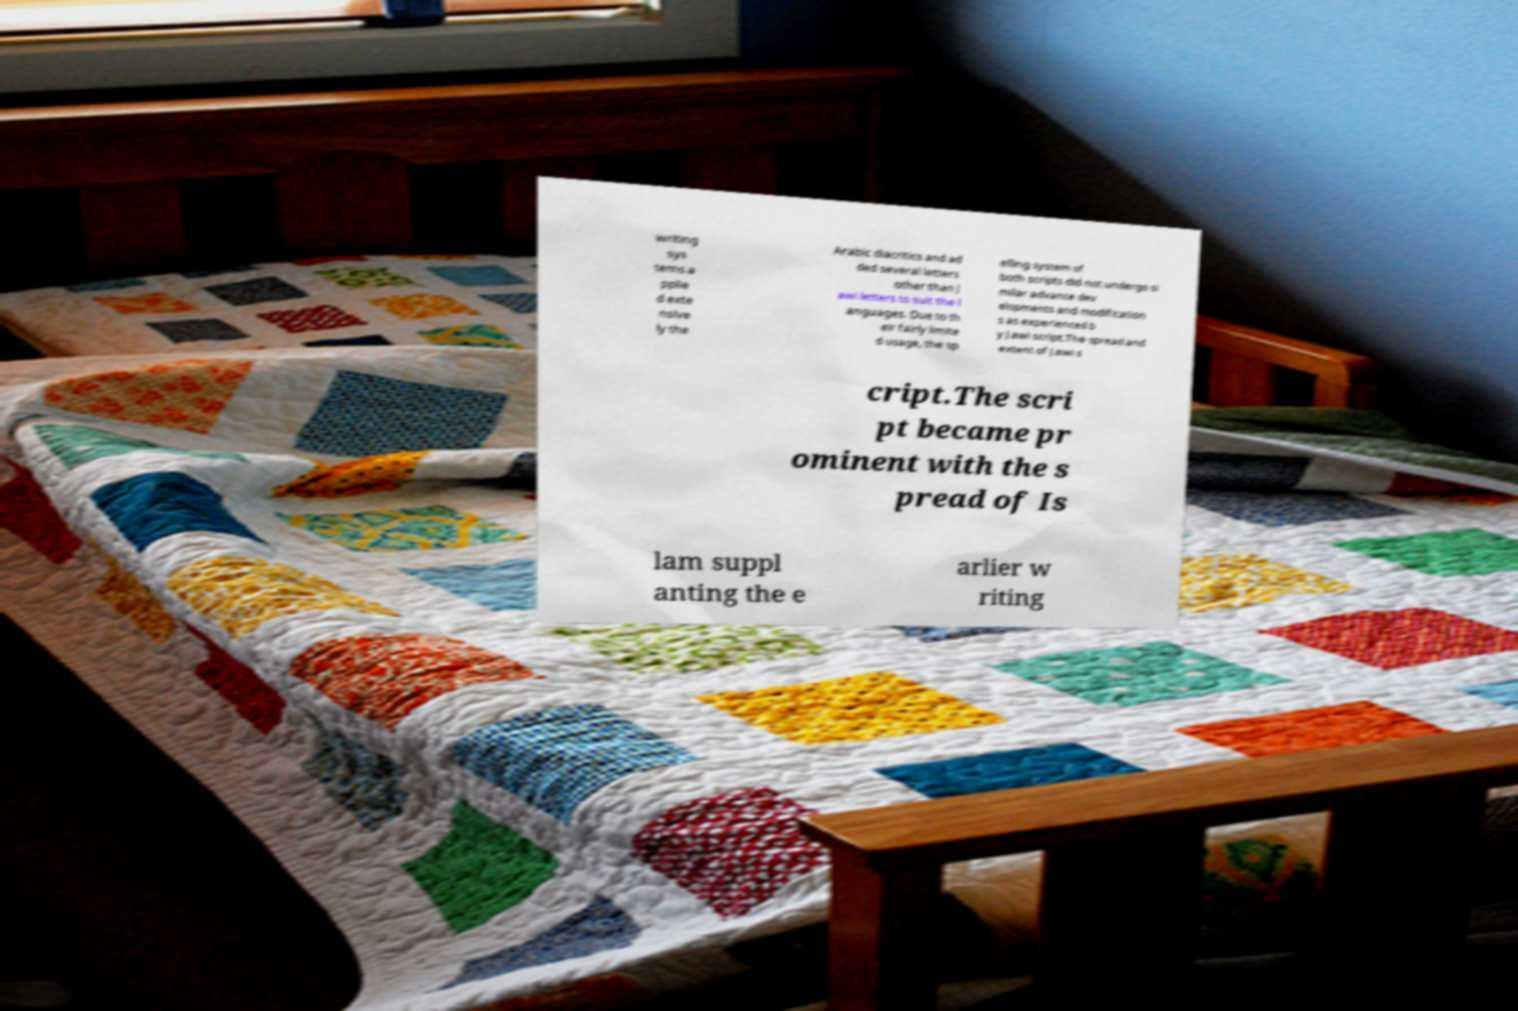Could you assist in decoding the text presented in this image and type it out clearly? writing sys tems a pplie d exte nsive ly the Arabic diacritics and ad ded several letters other than J awi letters to suit the l anguages. Due to th eir fairly limite d usage, the sp elling system of both scripts did not undergo si milar advance dev elopments and modification s as experienced b y Jawi script.The spread and extent of Jawi s cript.The scri pt became pr ominent with the s pread of Is lam suppl anting the e arlier w riting 